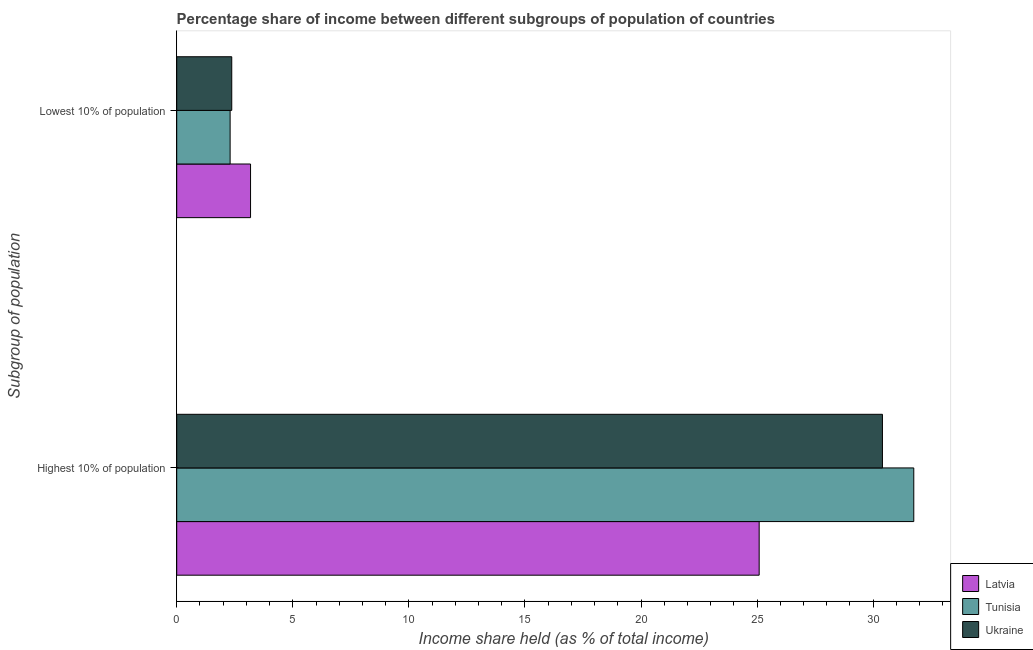How many different coloured bars are there?
Offer a terse response. 3. How many groups of bars are there?
Give a very brief answer. 2. Are the number of bars on each tick of the Y-axis equal?
Provide a short and direct response. Yes. How many bars are there on the 1st tick from the top?
Make the answer very short. 3. How many bars are there on the 1st tick from the bottom?
Provide a succinct answer. 3. What is the label of the 1st group of bars from the top?
Ensure brevity in your answer.  Lowest 10% of population. What is the income share held by highest 10% of the population in Ukraine?
Ensure brevity in your answer.  30.4. Across all countries, what is the maximum income share held by lowest 10% of the population?
Your answer should be compact. 3.18. Across all countries, what is the minimum income share held by highest 10% of the population?
Your response must be concise. 25.09. In which country was the income share held by highest 10% of the population maximum?
Offer a very short reply. Tunisia. In which country was the income share held by highest 10% of the population minimum?
Ensure brevity in your answer.  Latvia. What is the total income share held by lowest 10% of the population in the graph?
Offer a terse response. 7.85. What is the difference between the income share held by lowest 10% of the population in Latvia and that in Ukraine?
Offer a very short reply. 0.81. What is the difference between the income share held by highest 10% of the population in Tunisia and the income share held by lowest 10% of the population in Ukraine?
Offer a terse response. 29.38. What is the average income share held by highest 10% of the population per country?
Provide a succinct answer. 29.08. What is the difference between the income share held by highest 10% of the population and income share held by lowest 10% of the population in Ukraine?
Keep it short and to the point. 28.03. In how many countries, is the income share held by highest 10% of the population greater than 31 %?
Offer a terse response. 1. What is the ratio of the income share held by lowest 10% of the population in Ukraine to that in Latvia?
Ensure brevity in your answer.  0.75. Is the income share held by lowest 10% of the population in Tunisia less than that in Latvia?
Give a very brief answer. Yes. What does the 1st bar from the top in Lowest 10% of population represents?
Provide a succinct answer. Ukraine. What does the 2nd bar from the bottom in Lowest 10% of population represents?
Provide a succinct answer. Tunisia. How many bars are there?
Make the answer very short. 6. How many countries are there in the graph?
Provide a succinct answer. 3. What is the difference between two consecutive major ticks on the X-axis?
Provide a short and direct response. 5. Are the values on the major ticks of X-axis written in scientific E-notation?
Ensure brevity in your answer.  No. Does the graph contain grids?
Offer a very short reply. No. Where does the legend appear in the graph?
Offer a very short reply. Bottom right. How many legend labels are there?
Provide a succinct answer. 3. What is the title of the graph?
Make the answer very short. Percentage share of income between different subgroups of population of countries. What is the label or title of the X-axis?
Give a very brief answer. Income share held (as % of total income). What is the label or title of the Y-axis?
Provide a succinct answer. Subgroup of population. What is the Income share held (as % of total income) in Latvia in Highest 10% of population?
Give a very brief answer. 25.09. What is the Income share held (as % of total income) of Tunisia in Highest 10% of population?
Give a very brief answer. 31.75. What is the Income share held (as % of total income) in Ukraine in Highest 10% of population?
Ensure brevity in your answer.  30.4. What is the Income share held (as % of total income) of Latvia in Lowest 10% of population?
Your response must be concise. 3.18. What is the Income share held (as % of total income) of Ukraine in Lowest 10% of population?
Your answer should be very brief. 2.37. Across all Subgroup of population, what is the maximum Income share held (as % of total income) of Latvia?
Offer a terse response. 25.09. Across all Subgroup of population, what is the maximum Income share held (as % of total income) in Tunisia?
Ensure brevity in your answer.  31.75. Across all Subgroup of population, what is the maximum Income share held (as % of total income) of Ukraine?
Your answer should be compact. 30.4. Across all Subgroup of population, what is the minimum Income share held (as % of total income) in Latvia?
Give a very brief answer. 3.18. Across all Subgroup of population, what is the minimum Income share held (as % of total income) in Tunisia?
Ensure brevity in your answer.  2.3. Across all Subgroup of population, what is the minimum Income share held (as % of total income) in Ukraine?
Ensure brevity in your answer.  2.37. What is the total Income share held (as % of total income) of Latvia in the graph?
Make the answer very short. 28.27. What is the total Income share held (as % of total income) in Tunisia in the graph?
Offer a very short reply. 34.05. What is the total Income share held (as % of total income) of Ukraine in the graph?
Make the answer very short. 32.77. What is the difference between the Income share held (as % of total income) of Latvia in Highest 10% of population and that in Lowest 10% of population?
Offer a very short reply. 21.91. What is the difference between the Income share held (as % of total income) of Tunisia in Highest 10% of population and that in Lowest 10% of population?
Your answer should be very brief. 29.45. What is the difference between the Income share held (as % of total income) in Ukraine in Highest 10% of population and that in Lowest 10% of population?
Provide a short and direct response. 28.03. What is the difference between the Income share held (as % of total income) of Latvia in Highest 10% of population and the Income share held (as % of total income) of Tunisia in Lowest 10% of population?
Offer a very short reply. 22.79. What is the difference between the Income share held (as % of total income) of Latvia in Highest 10% of population and the Income share held (as % of total income) of Ukraine in Lowest 10% of population?
Give a very brief answer. 22.72. What is the difference between the Income share held (as % of total income) of Tunisia in Highest 10% of population and the Income share held (as % of total income) of Ukraine in Lowest 10% of population?
Provide a succinct answer. 29.38. What is the average Income share held (as % of total income) of Latvia per Subgroup of population?
Make the answer very short. 14.13. What is the average Income share held (as % of total income) of Tunisia per Subgroup of population?
Your answer should be compact. 17.02. What is the average Income share held (as % of total income) in Ukraine per Subgroup of population?
Your response must be concise. 16.39. What is the difference between the Income share held (as % of total income) in Latvia and Income share held (as % of total income) in Tunisia in Highest 10% of population?
Offer a terse response. -6.66. What is the difference between the Income share held (as % of total income) in Latvia and Income share held (as % of total income) in Ukraine in Highest 10% of population?
Keep it short and to the point. -5.31. What is the difference between the Income share held (as % of total income) in Tunisia and Income share held (as % of total income) in Ukraine in Highest 10% of population?
Provide a short and direct response. 1.35. What is the difference between the Income share held (as % of total income) of Latvia and Income share held (as % of total income) of Tunisia in Lowest 10% of population?
Give a very brief answer. 0.88. What is the difference between the Income share held (as % of total income) in Latvia and Income share held (as % of total income) in Ukraine in Lowest 10% of population?
Provide a succinct answer. 0.81. What is the difference between the Income share held (as % of total income) of Tunisia and Income share held (as % of total income) of Ukraine in Lowest 10% of population?
Make the answer very short. -0.07. What is the ratio of the Income share held (as % of total income) of Latvia in Highest 10% of population to that in Lowest 10% of population?
Your response must be concise. 7.89. What is the ratio of the Income share held (as % of total income) of Tunisia in Highest 10% of population to that in Lowest 10% of population?
Give a very brief answer. 13.8. What is the ratio of the Income share held (as % of total income) of Ukraine in Highest 10% of population to that in Lowest 10% of population?
Offer a terse response. 12.83. What is the difference between the highest and the second highest Income share held (as % of total income) of Latvia?
Ensure brevity in your answer.  21.91. What is the difference between the highest and the second highest Income share held (as % of total income) of Tunisia?
Keep it short and to the point. 29.45. What is the difference between the highest and the second highest Income share held (as % of total income) of Ukraine?
Your answer should be compact. 28.03. What is the difference between the highest and the lowest Income share held (as % of total income) in Latvia?
Your answer should be compact. 21.91. What is the difference between the highest and the lowest Income share held (as % of total income) in Tunisia?
Offer a very short reply. 29.45. What is the difference between the highest and the lowest Income share held (as % of total income) in Ukraine?
Offer a terse response. 28.03. 